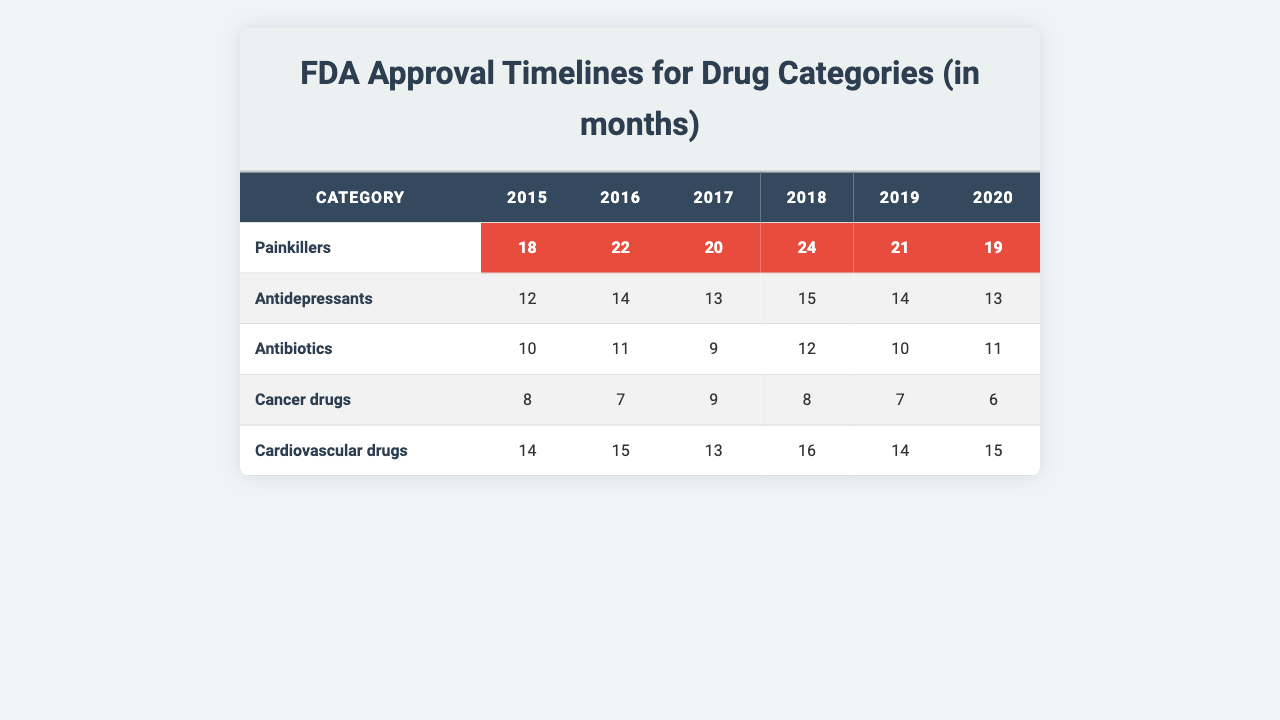What was the highest approval time for Painkillers? Looking at the Painkillers row, the highest value is 24 months in 2018.
Answer: 24 months Which category had the lowest approval time in 2017? By examining the data for 2017, Cancer drugs had the lowest approval time at 9 months.
Answer: 9 months What is the average approval time for Antidepressants from 2015 to 2020? The total approval times for Antidepressants over these years are (12 + 14 + 13 + 15 + 14 + 13) = 81 months. Dividing this by 6 gives an average of 81/6 = 13.5 months.
Answer: 13.5 months Did the approval time for Painkillers decrease from 2015 to 2020? Yes, the approval time decreased from 18 months in 2015 to 19 months in 2020 when looking at the specific values for those years.
Answer: Yes What was the percentage increase in approval time for Cardiovascular drugs from 2015 to 2018? The approval time for Cardiovascular drugs increased from 14 months in 2015 to 16 months in 2018, which is an increase of (16 - 14) = 2 months. The percentage increase is (2/14) * 100 = 14.29%.
Answer: 14.29% Which category had the most stable approval timeline over the years? By examining the variations in the data, Antibiotics showed the least fluctuation with values mostly consistent around 10-12 months.
Answer: Antibiotics What is the total approval time for all drug categories in 2019? The total for all categories in 2019 can be calculated by adding the values: 21 (Painkillers) + 14 (Antidepressants) + 10 (Antibiotics) + 7 (Cancer drugs) + 14 (Cardiovascular drugs) = 66 months.
Answer: 66 months In which year did Antidepressants have their highest approval time? The highest approval time for Antidepressants was 15 months in 2018.
Answer: 2018 Are there any years where the approval time for Painkillers equaled the approval time for Cardiovascular drugs? Yes, in 2020, both Painkillers and Cardiovascular drugs had an approval time of 19 months.
Answer: Yes What was the overall trend in the approval time for Cancer drugs from 2015 to 2020? The approval time for Cancer drugs decreased from 8 months in 2015 to 6 months in 2020, indicating a declining trend.
Answer: Declining trend 